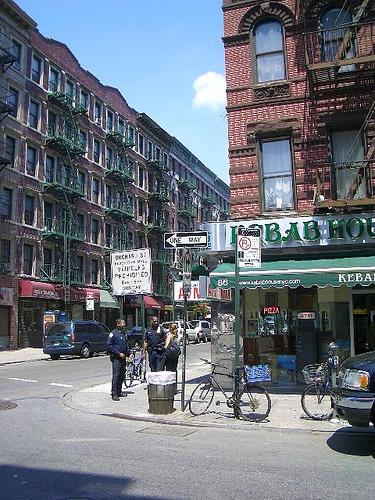How many people can be seen?
Quick response, please. 3. Are the flags in the picture?
Give a very brief answer. No. What kind of scene is this?
Quick response, please. City. How many men can be seen?
Quick response, please. 2. 